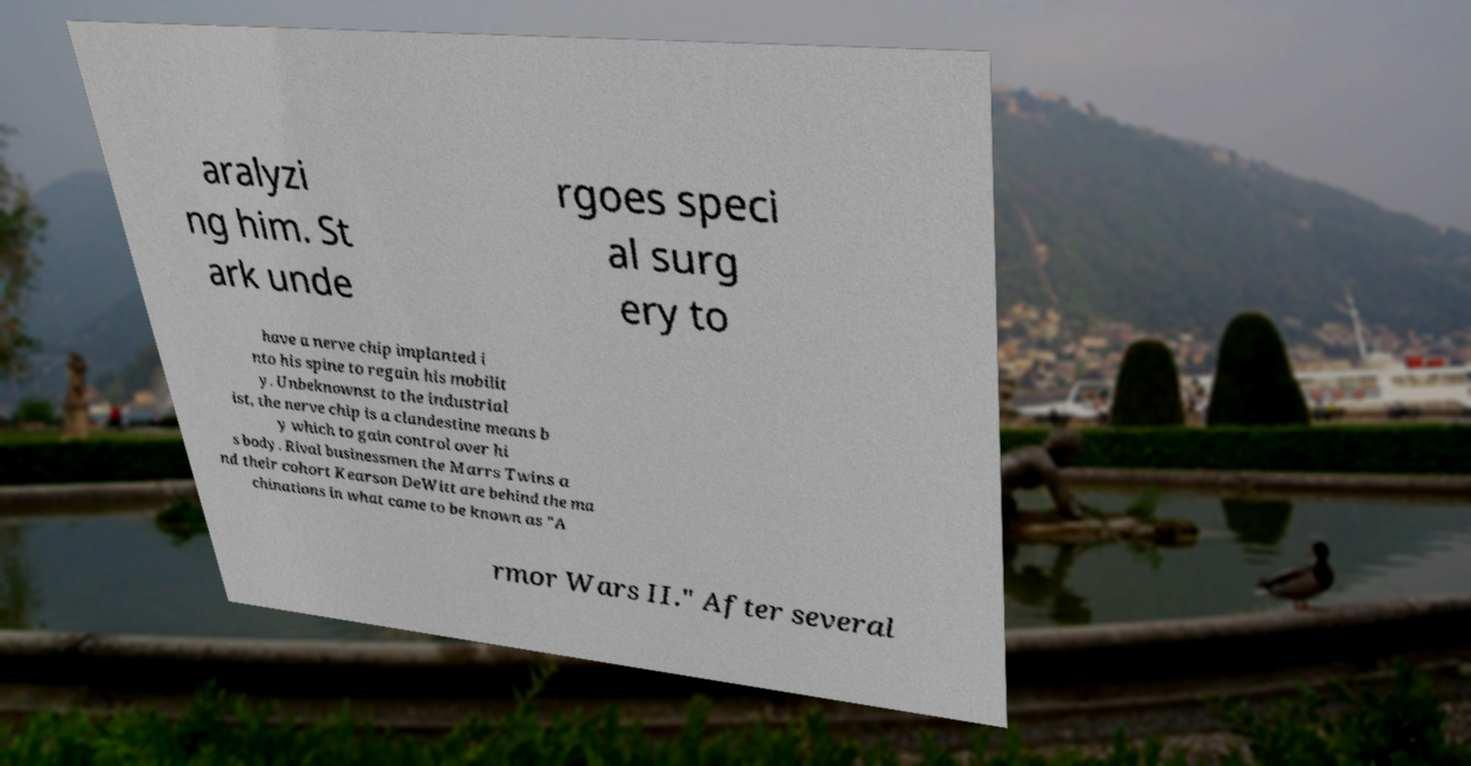I need the written content from this picture converted into text. Can you do that? aralyzi ng him. St ark unde rgoes speci al surg ery to have a nerve chip implanted i nto his spine to regain his mobilit y. Unbeknownst to the industrial ist, the nerve chip is a clandestine means b y which to gain control over hi s body. Rival businessmen the Marrs Twins a nd their cohort Kearson DeWitt are behind the ma chinations in what came to be known as "A rmor Wars II." After several 